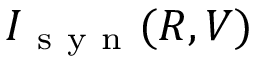Convert formula to latex. <formula><loc_0><loc_0><loc_500><loc_500>I _ { s y n } ( R , V )</formula> 